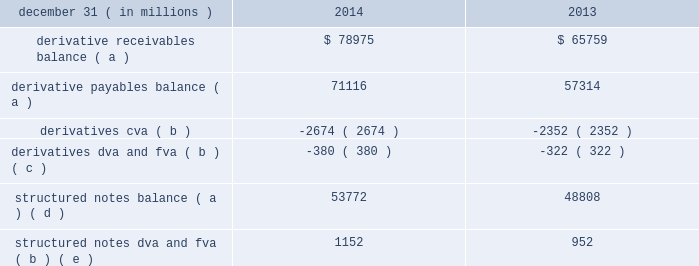Notes to consolidated financial statements 196 jpmorgan chase & co./2014 annual report credit and funding adjustments when determining the fair value of an instrument , it may be necessary to record adjustments to the firm 2019s estimates of fair value in order to reflect counterparty credit quality , the firm 2019s own creditworthiness , and the impact of funding : 2022 credit valuation adjustments ( 201ccva 201d ) are taken to reflect the credit quality of a counterparty in the valuation of derivatives .
Cva are necessary when the market price ( or parameter ) is not indicative of the credit quality of the counterparty .
As few classes of derivative contracts are listed on an exchange , derivative positions are predominantly valued using models that use as their basis observable market parameters .
An adjustment therefore may be necessary to reflect the credit quality of each derivative counterparty to arrive at fair value .
The firm estimates derivatives cva using a scenario analysis to estimate the expected credit exposure across all of the firm 2019s positions with each counterparty , and then estimates losses as a result of a counterparty credit event .
The key inputs to this methodology are ( i ) the expected positive exposure to each counterparty based on a simulation that assumes the current population of existing derivatives with each counterparty remains unchanged and considers contractual factors designed to mitigate the firm 2019s credit exposure , such as collateral and legal rights of offset ; ( ii ) the probability of a default event occurring for each counterparty , as derived from observed or estimated cds spreads ; and ( iii ) estimated recovery rates implied by cds , adjusted to consider the differences in recovery rates as a derivative creditor relative to those reflected in cds spreads , which generally reflect senior unsecured creditor risk .
As such , the firm estimates derivatives cva relative to the relevant benchmark interest rate .
2022 dva is taken to reflect the credit quality of the firm in the valuation of liabilities measured at fair value .
The dva calculation methodology is generally consistent with the cva methodology described above and incorporates jpmorgan chase 2019s credit spread as observed through the cds market to estimate the probability of default and loss given default as a result of a systemic event affecting the firm .
Structured notes dva is estimated using the current fair value of the structured note as the exposure amount , and is otherwise consistent with the derivative dva methodology .
2022 the firm incorporates the impact of funding in its valuation estimates where there is evidence that a market participant in the principal market would incorporate it in a transfer of the instrument .
As a result , the fair value of collateralized derivatives is estimated by discounting expected future cash flows at the relevant overnight indexed swap ( 201cois 201d ) rate given the underlying collateral agreement with the counterparty .
Effective in 2013 , the firm implemented a fva framework to incorporate the impact of funding into its valuation estimates for uncollateralized ( including partially collateralized ) over- the-counter ( 201cotc 201d ) derivatives and structured notes .
The firm 2019s fva framework leverages its existing cva and dva calculation methodologies , and considers the fact that the firm 2019s own credit risk is a significant component of funding costs .
The key inputs are : ( i ) the expected funding requirements arising from the firm 2019s positions with each counterparty and collateral arrangements ; ( ii ) for assets , the estimated market funding cost in the principal market ; and ( iii ) for liabilities , the hypothetical market funding cost for a transfer to a market participant with a similar credit standing as the firm .
Upon the implementation of the fva framework in 2013 , the firm recorded a one time $ 1.5 billion loss in principal transactions revenue that was recorded in the cib .
While the fva framework applies to both assets and liabilities , the loss on implementation largely related to uncollateralized derivative receivables given that the impact of the firm 2019s own credit risk , which is a significant component of funding costs , was already incorporated in the valuation of liabilities through the application of dva .
The table provides the credit and funding adjustments , excluding the effect of any associated hedging activities , reflected within the consolidated balance sheets as of the dates indicated. .
Derivative receivables balance ( a ) $ 78975 $ 65759 derivative payables balance ( a ) 71116 57314 derivatives cva ( b ) ( 2674 ) ( 2352 ) derivatives dva and fva ( b ) ( c ) ( 380 ) ( 322 ) structured notes balance ( a ) ( d ) 53772 48808 structured notes dva and fva ( b ) ( e ) 1152 952 ( a ) balances are presented net of applicable cva and dva/fva .
( b ) positive cva and dva/fva represent amounts that increased receivable balances or decreased payable balances ; negative cva and dva/fva represent amounts that decreased receivable balances or increased payable balances .
( c ) at december 31 , 2014 and 2013 , included derivatives dva of $ 714 million and $ 715 million , respectively .
( d ) structured notes are predominantly financial instruments containing embedded derivatives that are measured at fair value based on the firm 2019s election under the fair value option .
At december 31 , 2014 and 2013 , included $ 943 million and $ 1.1 billion , respectively , of financial instruments with no embedded derivative for which the fair value option has also been elected .
For further information on these elections , see note 4 .
( e ) at december 31 , 2014 and 2013 , included structured notes dva of $ 1.4 billion and $ 1.4 billion , respectively. .
By what total amount , from 2013 to 2014 , did total derivative receivable balances decrease or payable balances increase? 
Rationale: since negative cva/dva/fva result from decreased receivables or increased payables , add all negative cva/dva/fva for the two years .
Computations: ((2674 + 2352) + (380 + 322))
Answer: 5728.0. 